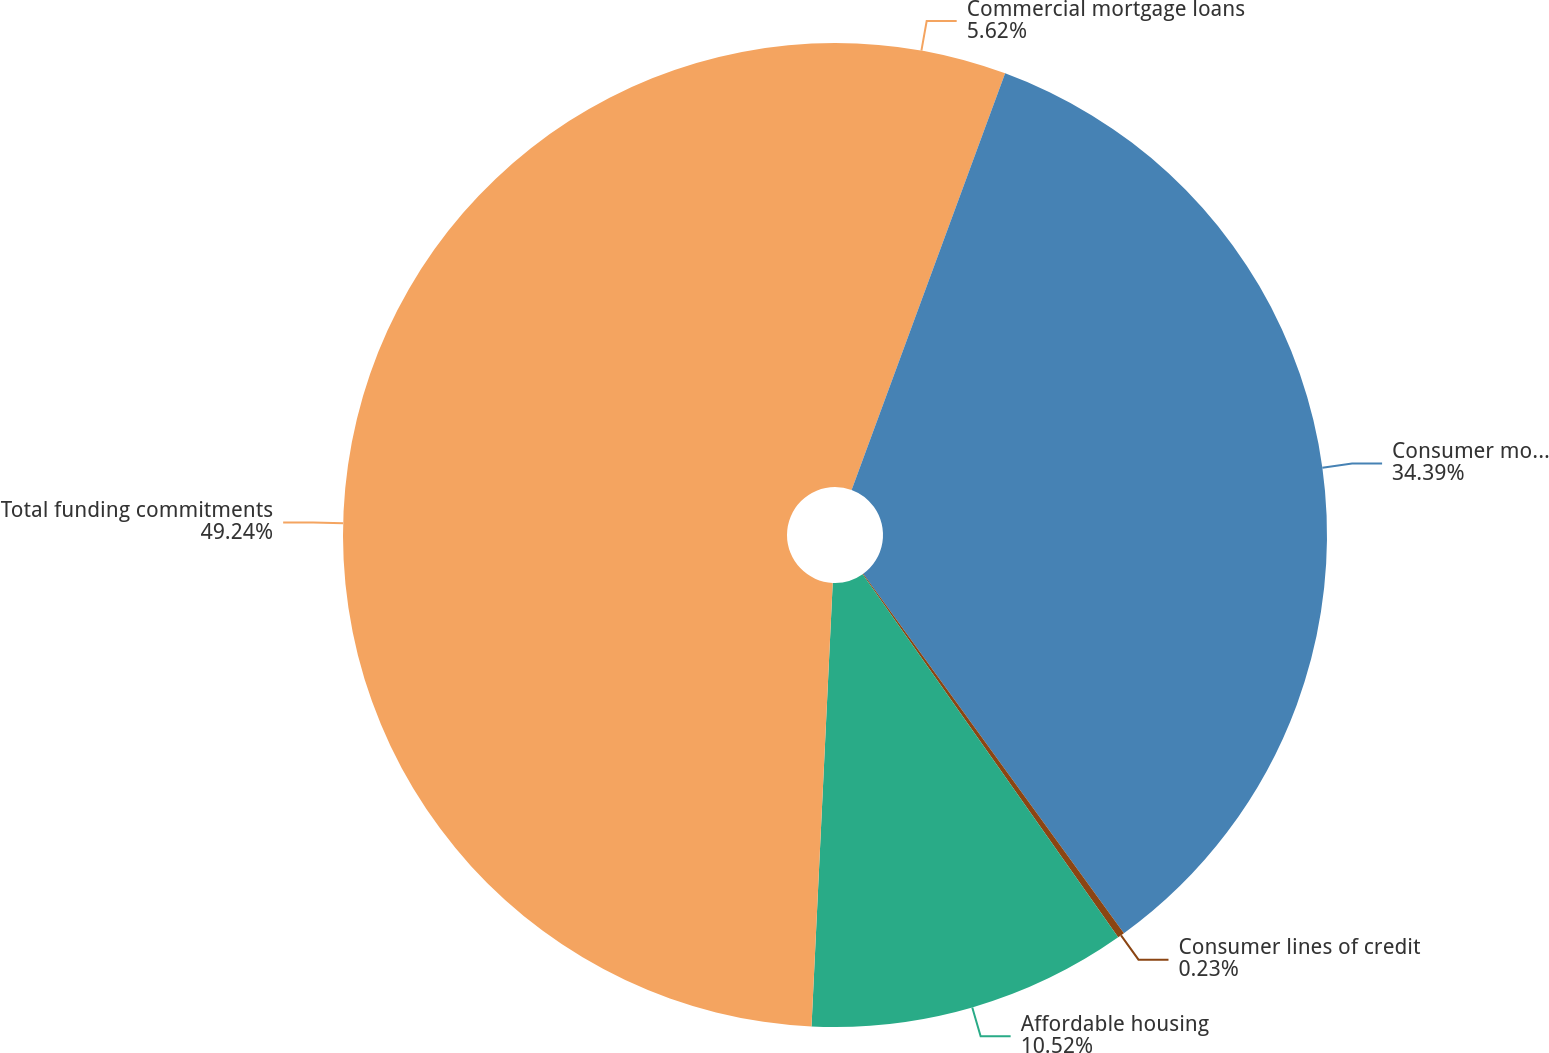<chart> <loc_0><loc_0><loc_500><loc_500><pie_chart><fcel>Commercial mortgage loans<fcel>Consumer mortgage loans<fcel>Consumer lines of credit<fcel>Affordable housing<fcel>Total funding commitments<nl><fcel>5.62%<fcel>34.39%<fcel>0.23%<fcel>10.52%<fcel>49.24%<nl></chart> 